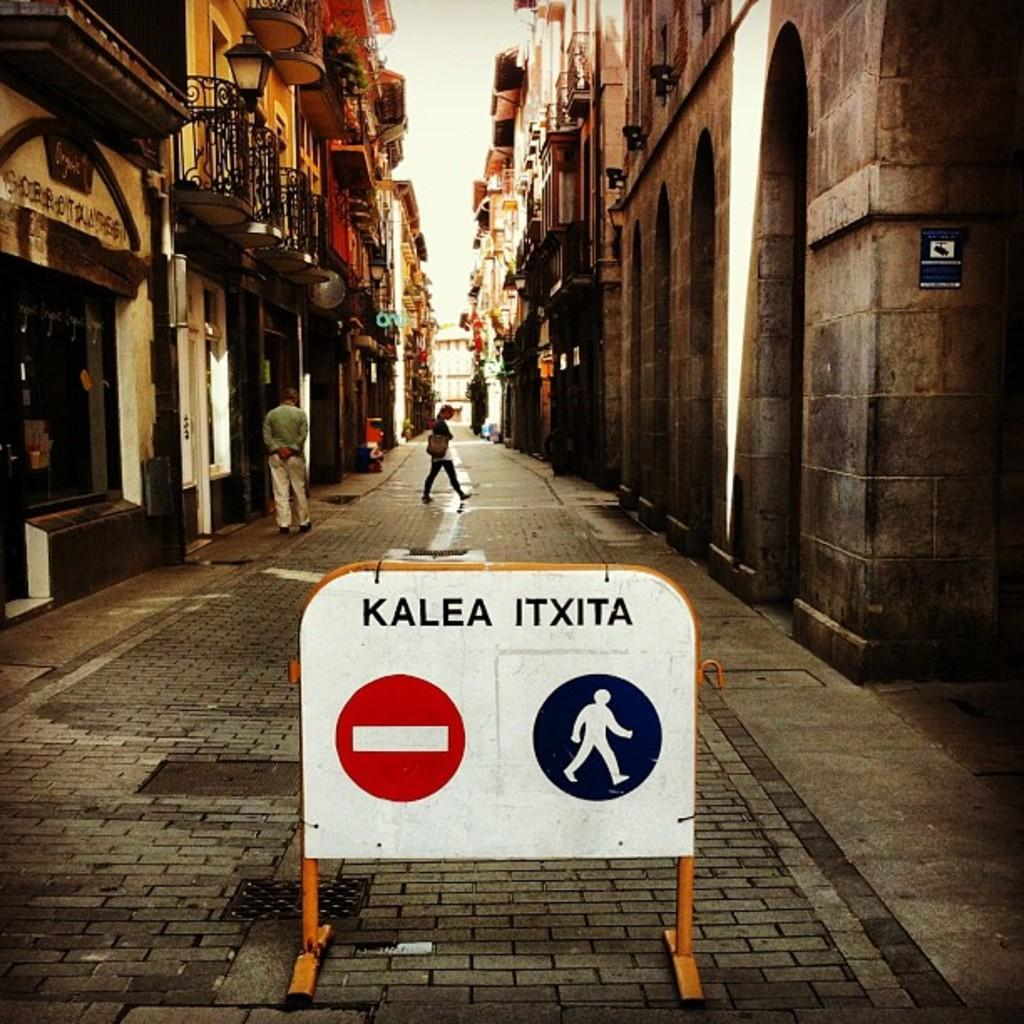Provide a one-sentence caption for the provided image. the street has a sign in the center that says Kalea Itxita. 